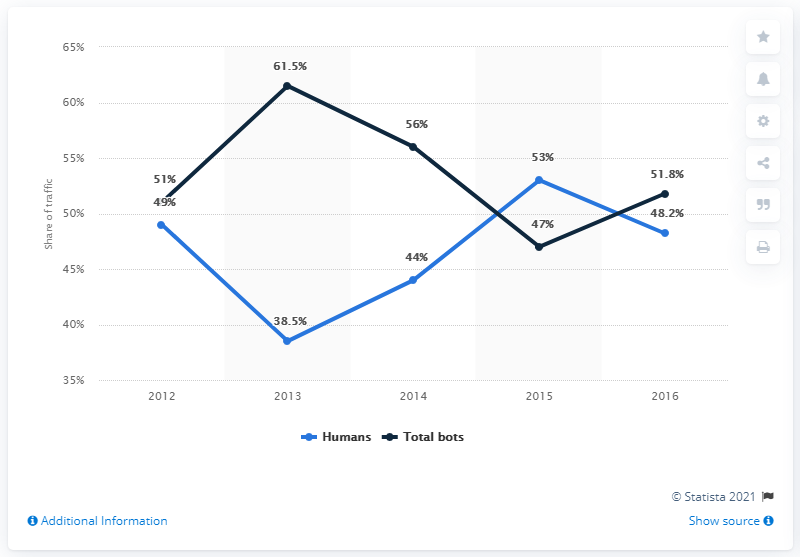Give some essential details in this illustration. In 2016, bots accounted for 51.8% of online traffic. 